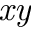<formula> <loc_0><loc_0><loc_500><loc_500>x y</formula> 